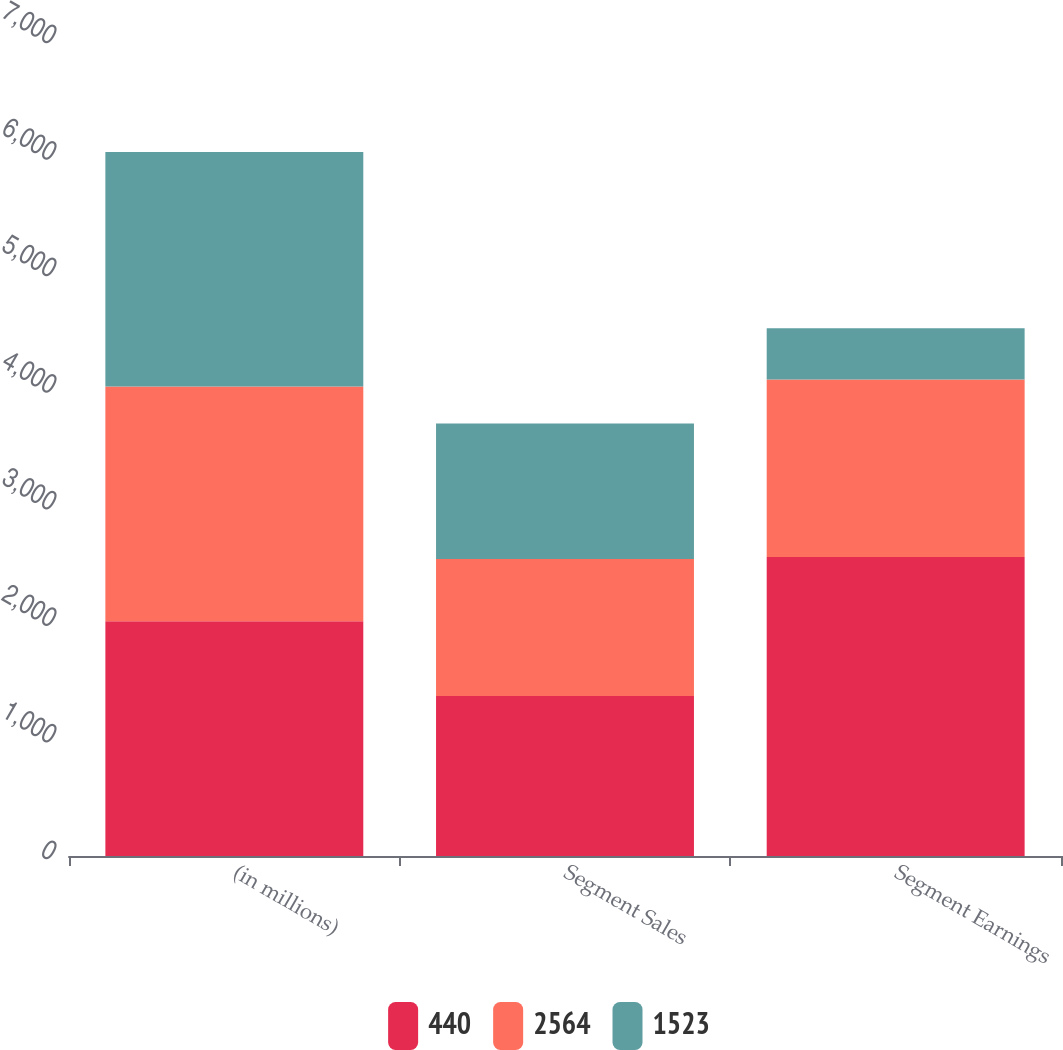Convert chart to OTSL. <chart><loc_0><loc_0><loc_500><loc_500><stacked_bar_chart><ecel><fcel>(in millions)<fcel>Segment Sales<fcel>Segment Earnings<nl><fcel>440<fcel>2014<fcel>1373<fcel>2564<nl><fcel>2564<fcel>2013<fcel>1174<fcel>1523<nl><fcel>1523<fcel>2012<fcel>1164<fcel>440<nl></chart> 